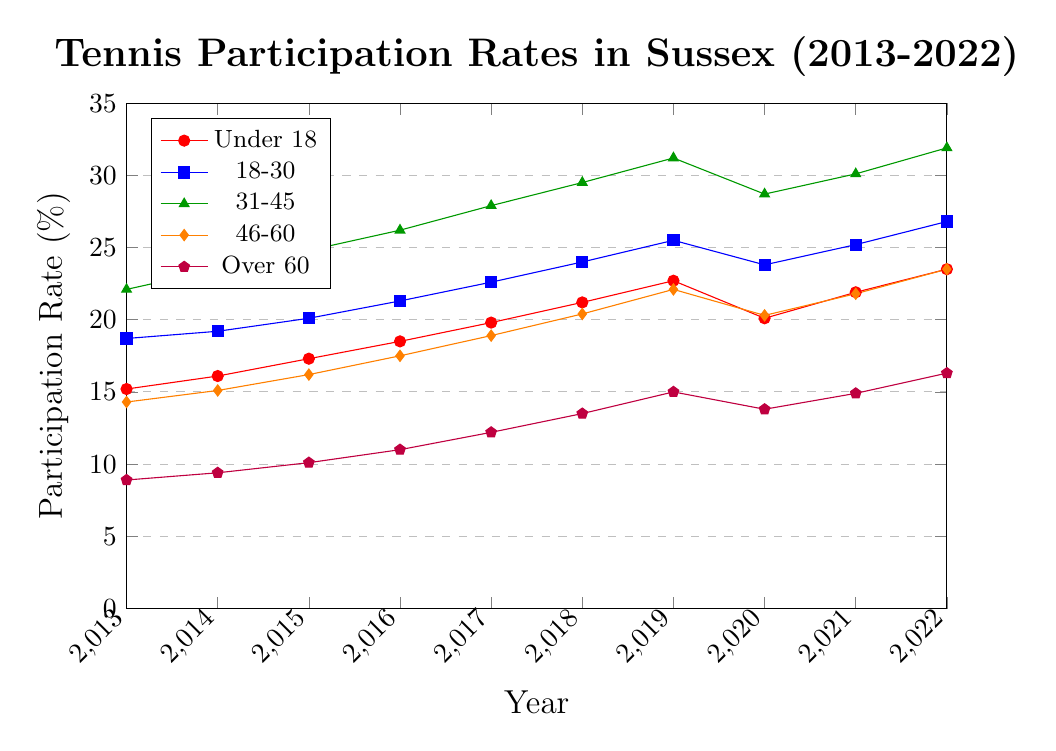What was the participation rate for the "Under 18" group in 2017? Look at the "Under 18" line (red) for the year 2017. The participation rate is marked on the y-axis.
Answer: 19.8% Which age group had the highest participation rate in 2022? Identify the highest value among all age groups for the year 2022. The "31-45" group (green) had the highest participation rate.
Answer: 31-45 By how much did the participation rate of the "46-60" group increase from 2013 to 2022? Subtract the participation rate in 2013 from the rate in 2022 for the "46-60" group (orange). (23.5 - 14.3 = 9.2)
Answer: 9.2% Which year showed a decline in the participation rate for the "18-30" group? Track the "18-30" line (blue) year by year and find the year where the rate decreased compared to the previous year. The decline happened from 2019 to 2020.
Answer: 2020 What is the average participation rate of the "Over 60" group over the decade? Sum up the participation rates of the "Over 60" group (purple) for all years and divide by the number of years. (8.9 + 9.4 + 10.1 + 11.0 + 12.2 + 13.5 + 15.0 + 13.8 + 14.9 + 16.3) / 10 = 12.1
Answer: 12.1% Which group had a higher participation rate in 2015, the "18-30" or "Under 18"? Compare the values for 2015 from both age groups. The "18-30" group (blue) had a higher rate.
Answer: 18-30 What is the overall trend for the "31-45" group from 2013 to 2022? Observe the line for the "31-45" group (green). The trend shows a general increase in participation.
Answer: Increasing Compare the change in participation rates from 2019 to 2020 for the "Under 18" and "31-45" groups. Which saw a greater change? Calculate the differences: "Under 18" (22.7 - 20.1 = 2.6), "31-45" (31.2 - 28.7 = 2.5). The "Under 18" group saw a greater change.
Answer: Under 18 What was the lowest participation rate recorded for any group in any year? Identify the lowest data point on the plot. The lowest participation rate was for the "Over 60" group (purple) in 2013.
Answer: 8.9% If the patterns continue, which age group is likely to have the highest increase over the next year? Assess the trend lines' slopes. The "31-45" group (green) consistently shows the steepest upward slope, suggesting it may continue to have the highest increase.
Answer: 31-45 